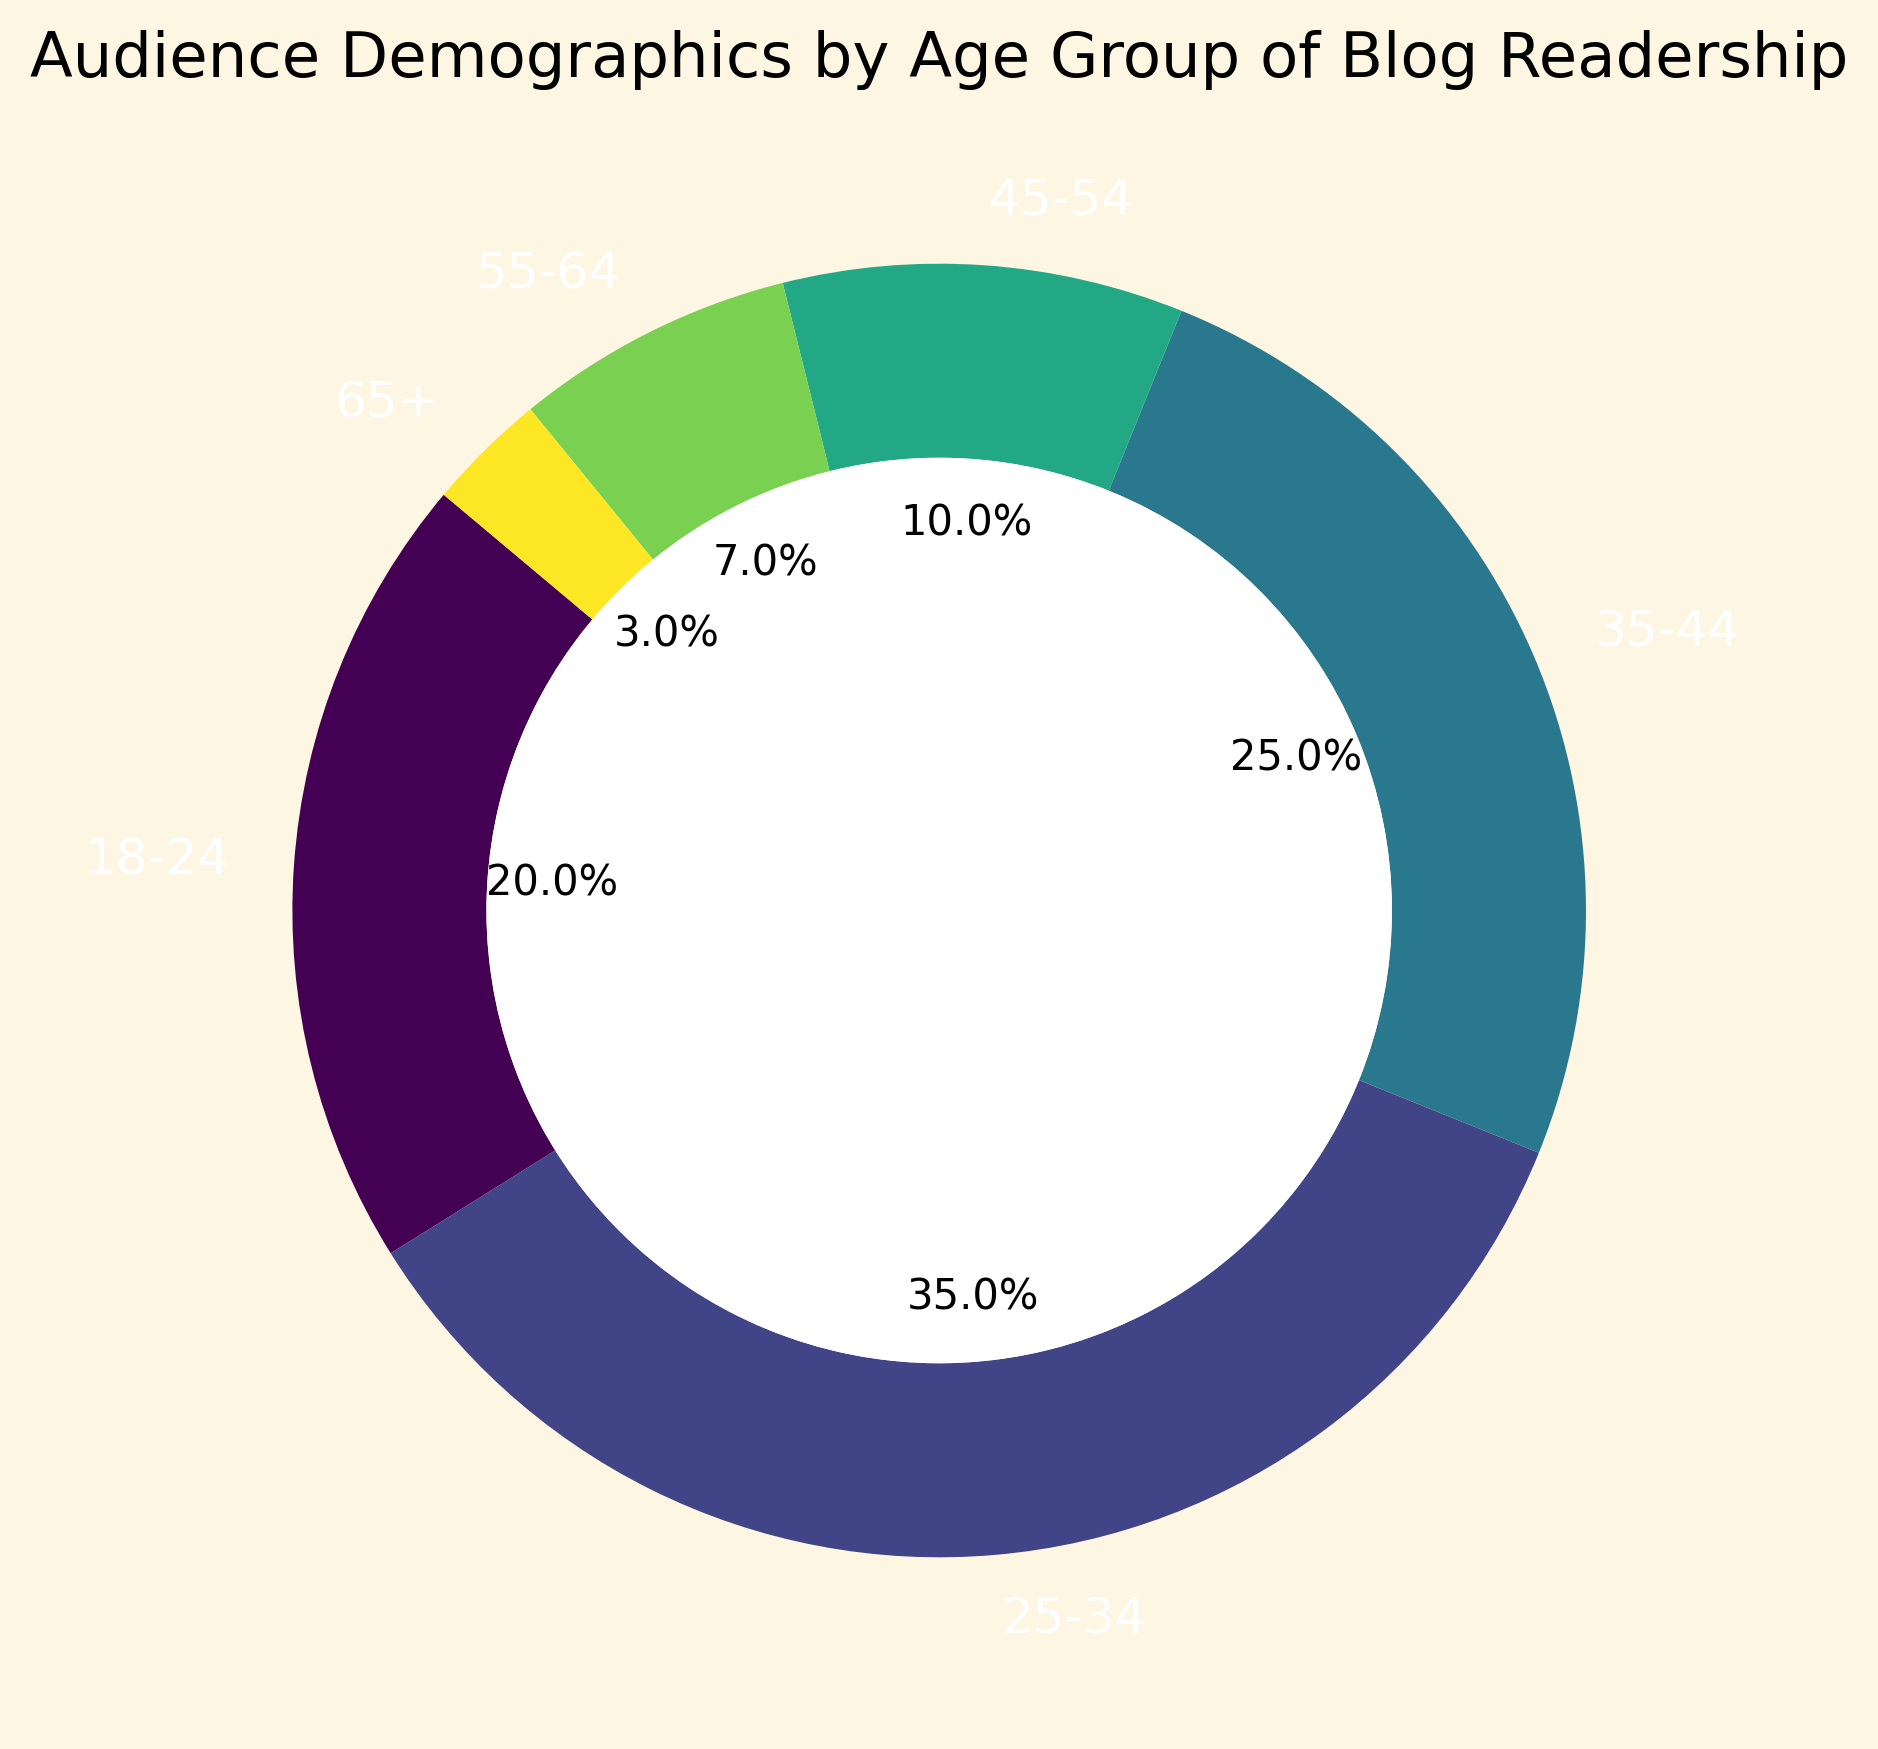what is the largest age group of the blog readership? The largest portion of the pie chart corresponds to the 25-34 age group, as indicated by the section occupying the most space with a label of 35%.
Answer: 25-34 Which age group represents less than 5% of the blog readership? The 65+ age group comprises only 3% of the blog readership, representing less than 5% as indicated by the pie chart.
Answer: 65+ What is the total percentage of blog readership for individuals aged 35-54? Adding together the percentages for the 35-44 age group (25%) and the 45-54 age group (10%) gives 35-44: 25% + 45-54: 10% = 35%.
Answer: 35% How does the 18-24 age group compare to the 55-64 age group in terms of blog readership? The 18-24 age group represents 20% of the readership, while the 55-64 age group accounts for only 7%. Therefore, the 18-24 group is significantly larger.
Answer: Larger What percentage of the blog readership is over the age of 44? Summing the 45-54 age group (10%), 55-64 age group (7%), and 65+ age group (3%), the total is 10% + 7% + 3% = 20%.
Answer: 20% What fraction of the blog readership is between the ages of 18 and 34? Adding the 18-24 age group (20%) and the 25-34 age group (35%) gives a total of 55%.
Answer: 55% Which age group occupies the smallest section of the pie chart? The pie chart shows that the 65+ age group with 3% occupies the smallest section.
Answer: 65+ Is the readership of the 35-44 age group higher than the combined readership of 55+ age groups? The 35-44 age group has 25%, while the combined total for the 55-64 (7%) and 65+ (3%) age groups is 7% + 3% = 10%. Therefore, the 35-44 age group is indeed higher.
Answer: Yes If you combine the 18-24 and 55-64 age groups, does their total percentage exceed that of the 25-34 age group? The combined total for 18-24 age group (20%) and 55-64 age group (7%) sums up to 27%. Comparing to 25-34 age group (35%), 27% is less.
Answer: No Which three age groups have the highest readership? The pie chart shows the age groups with the highest percentages: 25-34 (35%), 35-44 (25%), and 18-24 (20%).
Answer: 25-34, 35-44, 18-24 